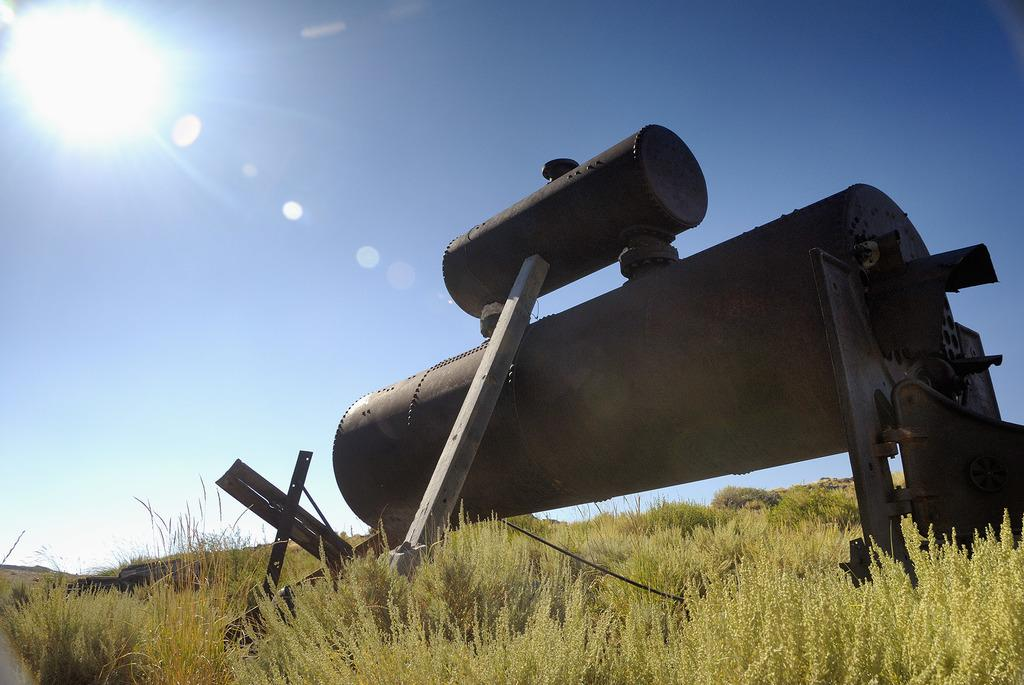What type of setting is depicted in the image? The image is an outside view. What can be seen in the image besides the natural environment? There is a metal object that appears to be a machine in the image. What type of vegetation is present on the ground in the image? There is grass on the ground in the image. What is visible at the top of the image? The sky is visible at the top of the image, and the sun is observable in the sky. What type of tree is growing in the middle of the machine in the image? There is no tree present in the image, and the machine is not depicted as having a tree growing in it. 